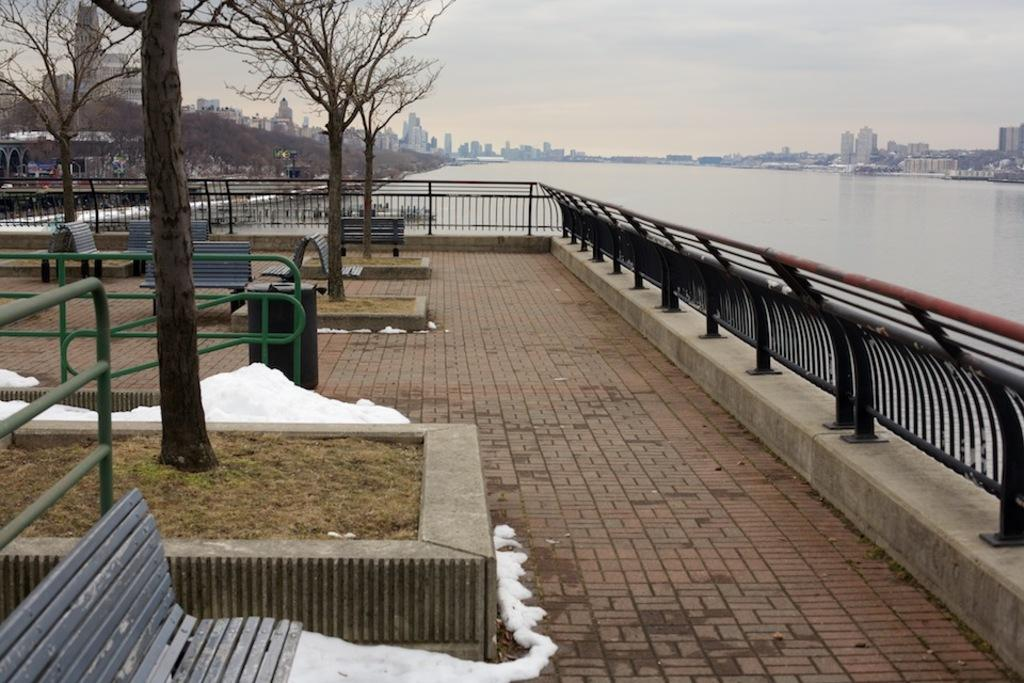What type of vegetation can be seen in the image? There are trees in the image. What type of seating is available in the image? There are benches in the image. What material is the railing made of in the image? The railing in the image is made of iron. What natural element is visible in the image? Water is visible in the image. What type of structures can be seen in the background of the image? There are buildings in the background of the image. What is visible in the sky in the image? The sky is visible in the background of the image. What advice does the manager give to the uncle in the image? There is no manager or uncle present in the image, so no such interaction can be observed. What type of nail is being hammered into the tree in the image? There is no nail being hammered into the tree in the image; there are only trees, benches, an iron railing, water, buildings, and the sky visible. 